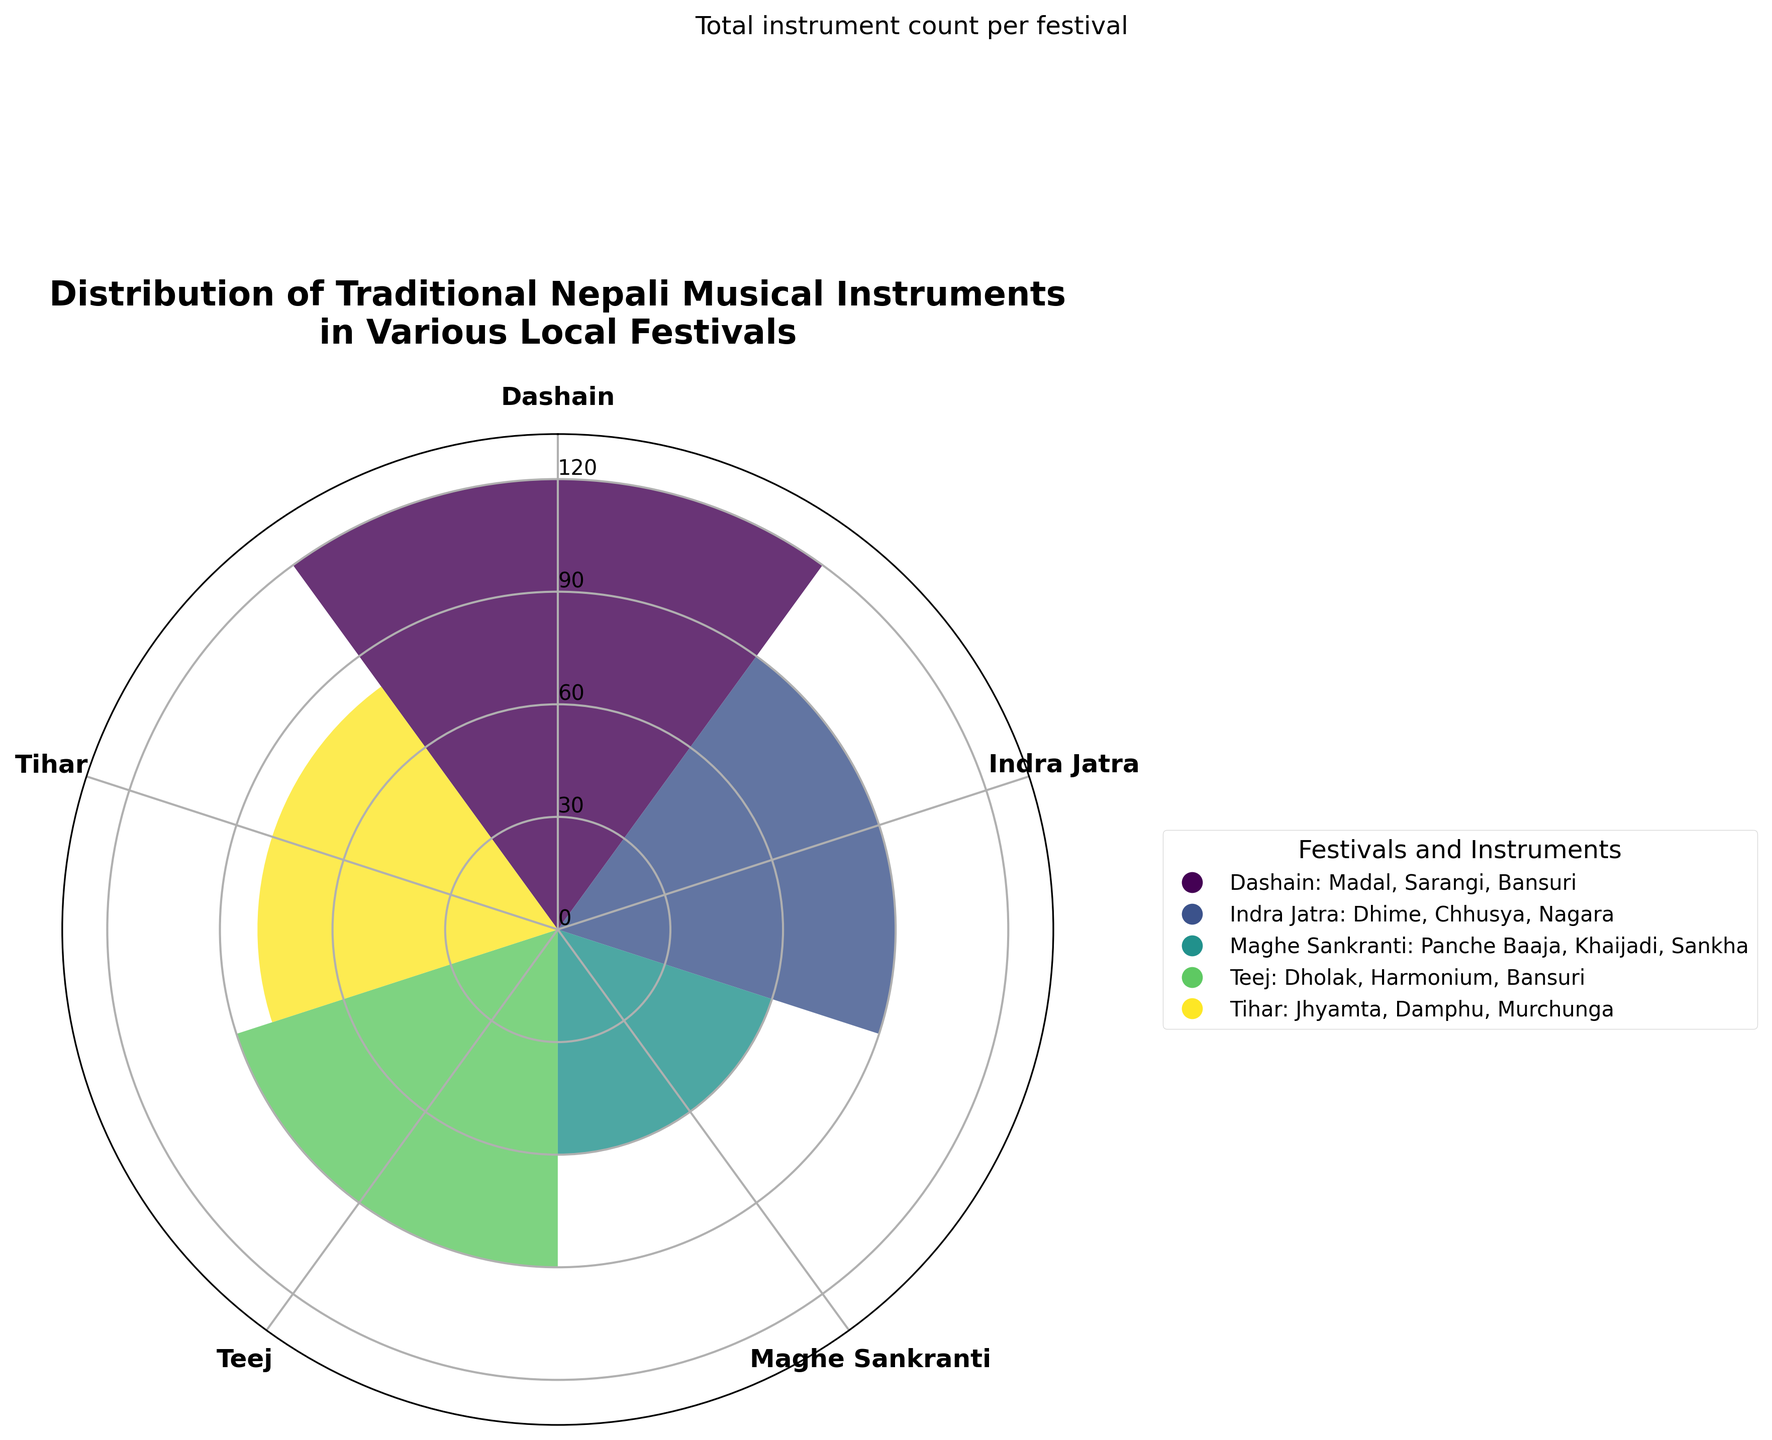What is the title of the chart? The title can be read directly from the top of the plot.
Answer: Distribution of Traditional Nepali Musical Instruments in Various Local Festivals How many festivals are represented in the chart? Count the number of unique festival labels mentioned around the polar chart.
Answer: 5 Which festival has the highest total count of traditional musical instruments? Check the height of the bars and identify the festival with the tallest bar.
Answer: Dashain Which festival has the lowest total count of traditional musical instruments? Identify the festival with the shortest bar in the chart.
Answer: Maghe Sankranti What are the three instruments played during Teej? Look at the legend to find the festival Teej and list the instruments mentioned.
Answer: Dholak, Harmonium, Bansuri Sum the total count of instruments for Tihar and Maghe Sankranti. Add the counts from the bars for Tihar and Maghe Sankranti.
Answer: 110 (25 + 35 + 20 + 25 + 20 + 15) How much greater is the total count of instruments for Dashain compared to Teej? Subtract the count for Teej from the count for Dashain.
Answer: 10 (120 - 110) Which musical instrument has the highest count during Dashain? Refer to the legend and check the counts associated with each instrument under Dashain.
Answer: Madal Do Indra Jatra and Teej have the same total number of traditional musical instruments? Compare the bar heights for Indra Jatra and Teej.
Answer: No How do the total counts of instruments used in Tihar and Indra Jatra compare? Compare the heights of the bars corresponding to Tihar and Indra Jatra.
Answer: Tihar has a higher count than Indra Jatra 